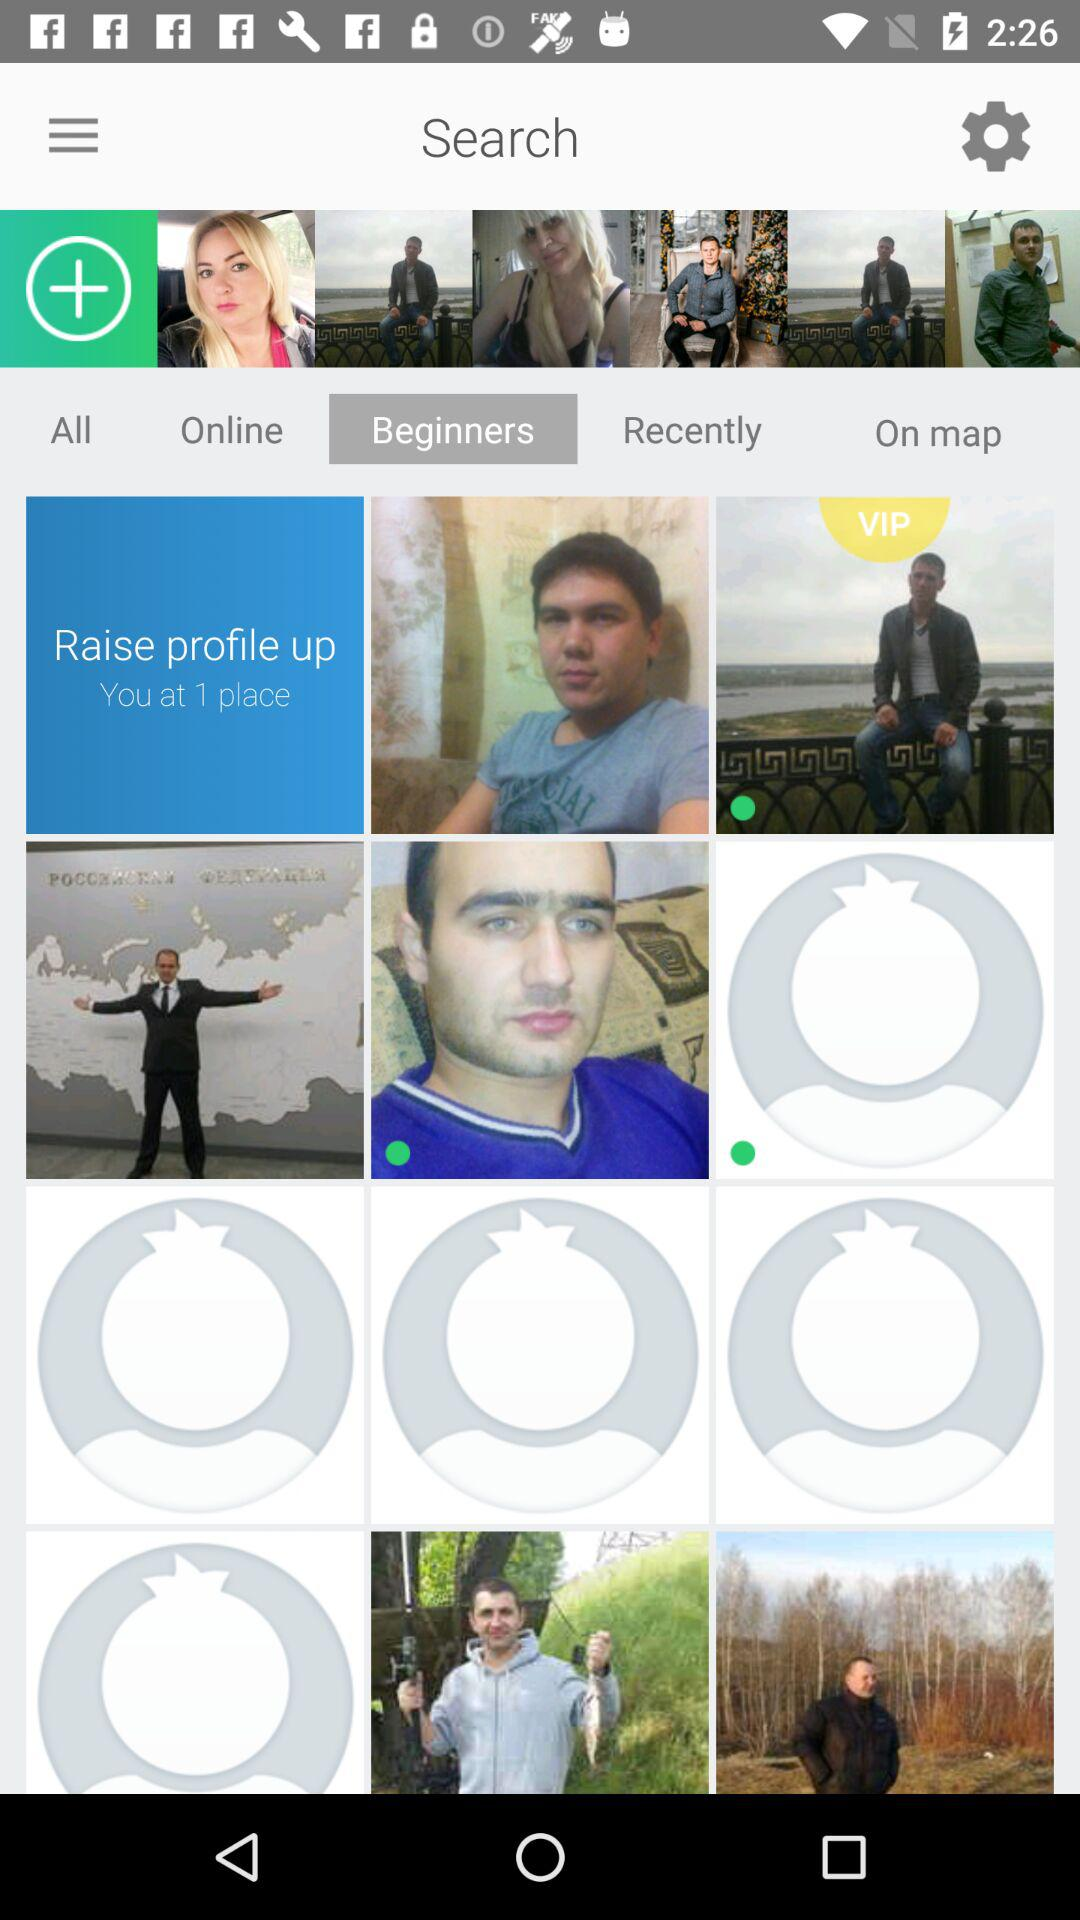Which tab is open? The opened tab is "Beginners". 